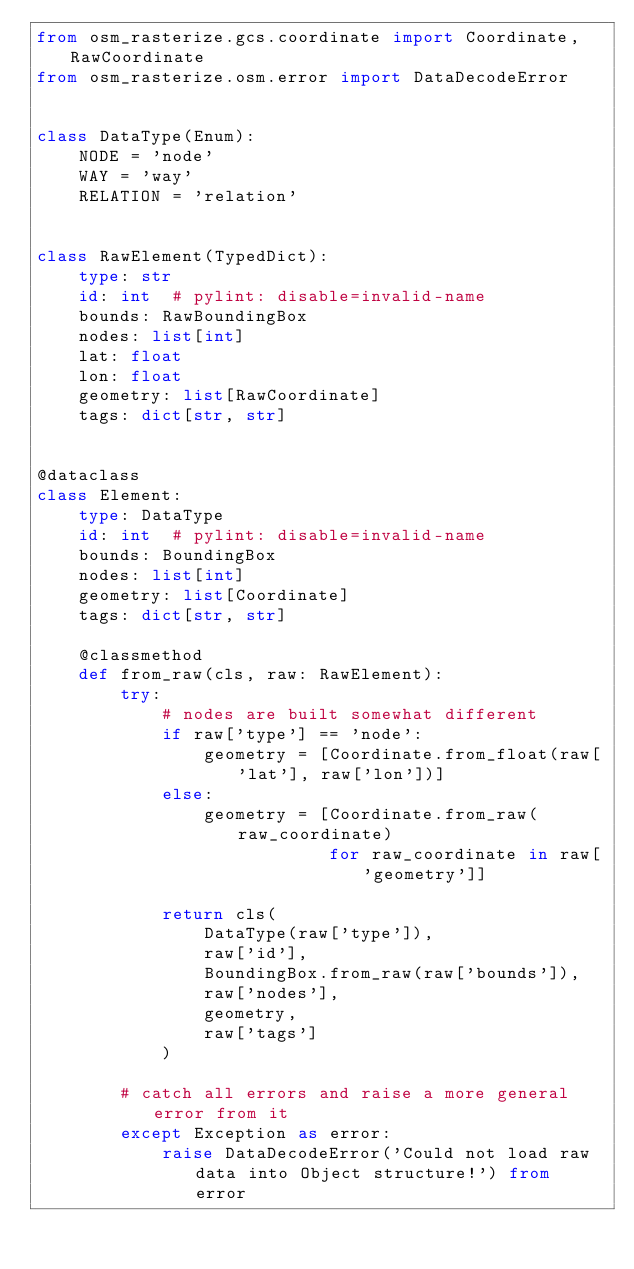Convert code to text. <code><loc_0><loc_0><loc_500><loc_500><_Python_>from osm_rasterize.gcs.coordinate import Coordinate, RawCoordinate
from osm_rasterize.osm.error import DataDecodeError


class DataType(Enum):
    NODE = 'node'
    WAY = 'way'
    RELATION = 'relation'


class RawElement(TypedDict):
    type: str
    id: int  # pylint: disable=invalid-name
    bounds: RawBoundingBox
    nodes: list[int]
    lat: float
    lon: float
    geometry: list[RawCoordinate]
    tags: dict[str, str]


@dataclass
class Element:
    type: DataType
    id: int  # pylint: disable=invalid-name
    bounds: BoundingBox
    nodes: list[int]
    geometry: list[Coordinate]
    tags: dict[str, str]

    @classmethod
    def from_raw(cls, raw: RawElement):
        try:
            # nodes are built somewhat different
            if raw['type'] == 'node':
                geometry = [Coordinate.from_float(raw['lat'], raw['lon'])]
            else:
                geometry = [Coordinate.from_raw(raw_coordinate)
                            for raw_coordinate in raw['geometry']]

            return cls(
                DataType(raw['type']),
                raw['id'],
                BoundingBox.from_raw(raw['bounds']),
                raw['nodes'],
                geometry,
                raw['tags']
            )

        # catch all errors and raise a more general error from it
        except Exception as error:
            raise DataDecodeError('Could not load raw data into Object structure!') from error
</code> 